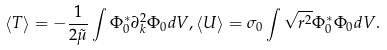Convert formula to latex. <formula><loc_0><loc_0><loc_500><loc_500>\left \langle T \right \rangle = - \frac { 1 } { 2 \tilde { \mu } } \int \Phi _ { 0 } ^ { * } \partial _ { k } ^ { 2 } \Phi _ { 0 } d V , \left \langle U \right \rangle = \sigma _ { 0 } \int \sqrt { { r } ^ { 2 } } \Phi _ { 0 } ^ { * } \Phi _ { 0 } d V .</formula> 